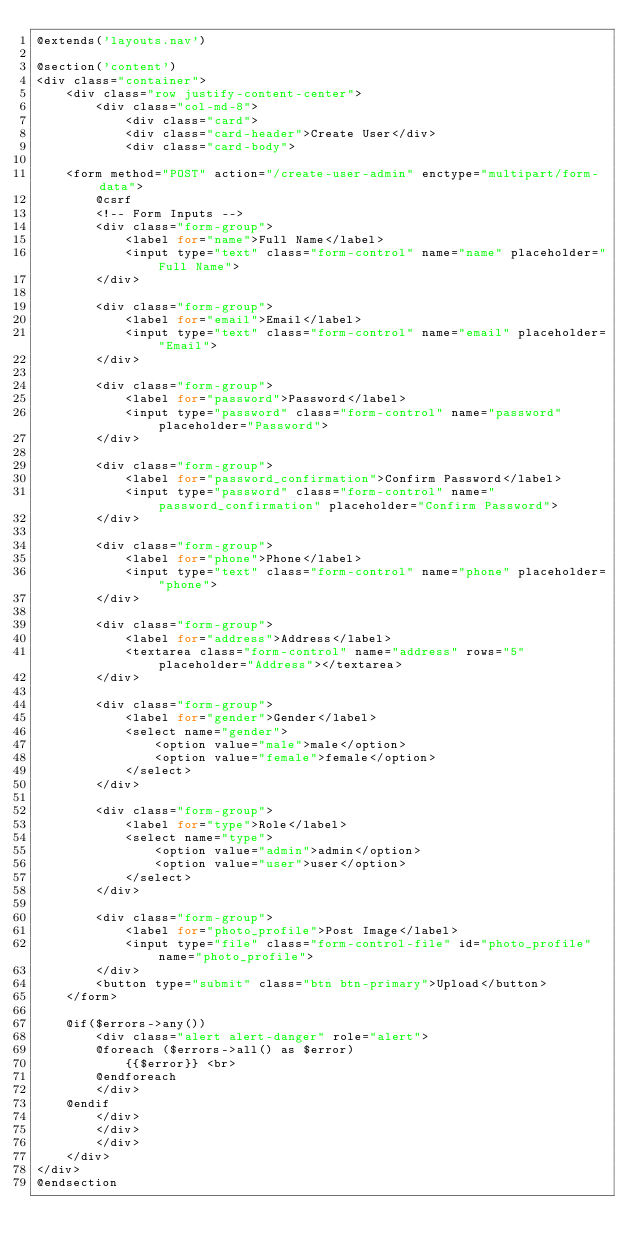<code> <loc_0><loc_0><loc_500><loc_500><_PHP_>@extends('layouts.nav')

@section('content')
<div class="container">
    <div class="row justify-content-center">
        <div class="col-md-8">
            <div class="card">
            <div class="card-header">Create User</div>
            <div class="card-body">

    <form method="POST" action="/create-user-admin" enctype="multipart/form-data">
        @csrf
        <!-- Form Inputs -->
        <div class="form-group">
            <label for="name">Full Name</label>
            <input type="text" class="form-control" name="name" placeholder="Full Name">
        </div>

        <div class="form-group">
            <label for="email">Email</label>
            <input type="text" class="form-control" name="email" placeholder="Email">
        </div>

        <div class="form-group">
            <label for="password">Password</label>
            <input type="password" class="form-control" name="password" placeholder="Password">
        </div>

        <div class="form-group">
            <label for="password_confirmation">Confirm Password</label>
            <input type="password" class="form-control" name="password_confirmation" placeholder="Confirm Password">
        </div>

        <div class="form-group">
            <label for="phone">Phone</label>
            <input type="text" class="form-control" name="phone" placeholder="phone">
        </div>

        <div class="form-group">
            <label for="address">Address</label>
            <textarea class="form-control" name="address" rows="5" placeholder="Address"></textarea>
        </div>

        <div class="form-group">
            <label for="gender">Gender</label>
            <select name="gender">
                <option value="male">male</option>
                <option value="female">female</option>
            </select>
        </div>

        <div class="form-group">
            <label for="type">Role</label>
            <select name="type">
                <option value="admin">admin</option>
                <option value="user">user</option>
            </select>
        </div>

        <div class="form-group">
            <label for="photo_profile">Post Image</label>
            <input type="file" class="form-control-file" id="photo_profile" name="photo_profile">
        </div>
        <button type="submit" class="btn btn-primary">Upload</button>
    </form>

    @if($errors->any())
        <div class="alert alert-danger" role="alert">
        @foreach ($errors->all() as $error)
            {{$error}} <br>
        @endforeach
        </div>
    @endif
        </div>
        </div>
        </div>
    </div>
</div>
@endsection
</code> 